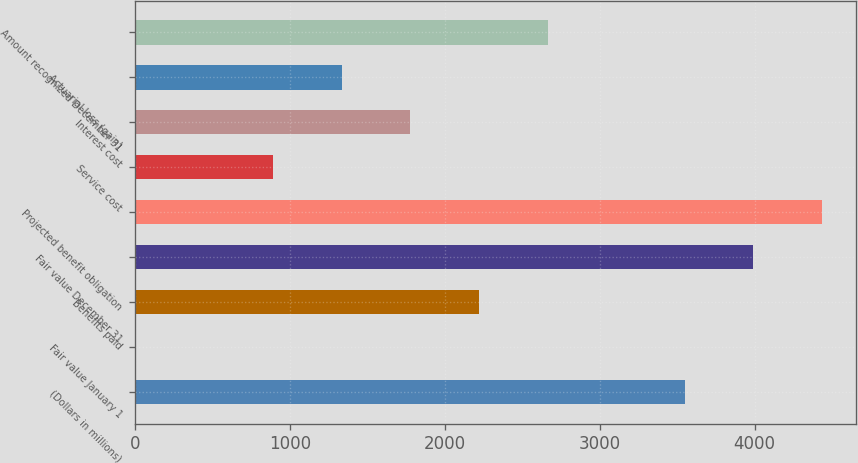Convert chart to OTSL. <chart><loc_0><loc_0><loc_500><loc_500><bar_chart><fcel>(Dollars in millions)<fcel>Fair value January 1<fcel>Benefits paid<fcel>Fair value December 31<fcel>Projected benefit obligation<fcel>Service cost<fcel>Interest cost<fcel>Actuarial loss (gain)<fcel>Amount recognized December 31<nl><fcel>3549.2<fcel>2<fcel>2219<fcel>3992.6<fcel>4436<fcel>888.8<fcel>1775.6<fcel>1332.2<fcel>2662.4<nl></chart> 